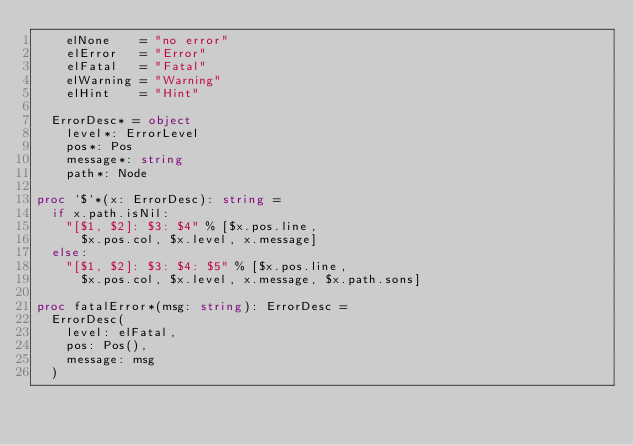Convert code to text. <code><loc_0><loc_0><loc_500><loc_500><_Nim_>    elNone    = "no error"
    elError   = "Error"
    elFatal   = "Fatal"
    elWarning = "Warning"
    elHint    = "Hint"

  ErrorDesc* = object
    level*: ErrorLevel
    pos*: Pos
    message*: string
    path*: Node

proc `$`*(x: ErrorDesc): string =
  if x.path.isNil:
    "[$1, $2]: $3: $4" % [$x.pos.line,
      $x.pos.col, $x.level, x.message]
  else:
    "[$1, $2]: $3: $4: $5" % [$x.pos.line,
      $x.pos.col, $x.level, x.message, $x.path.sons]

proc fatalError*(msg: string): ErrorDesc =
  ErrorDesc(
    level: elFatal,
    pos: Pos(),
    message: msg
  )
</code> 